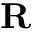Convert formula to latex. <formula><loc_0><loc_0><loc_500><loc_500>R</formula> 